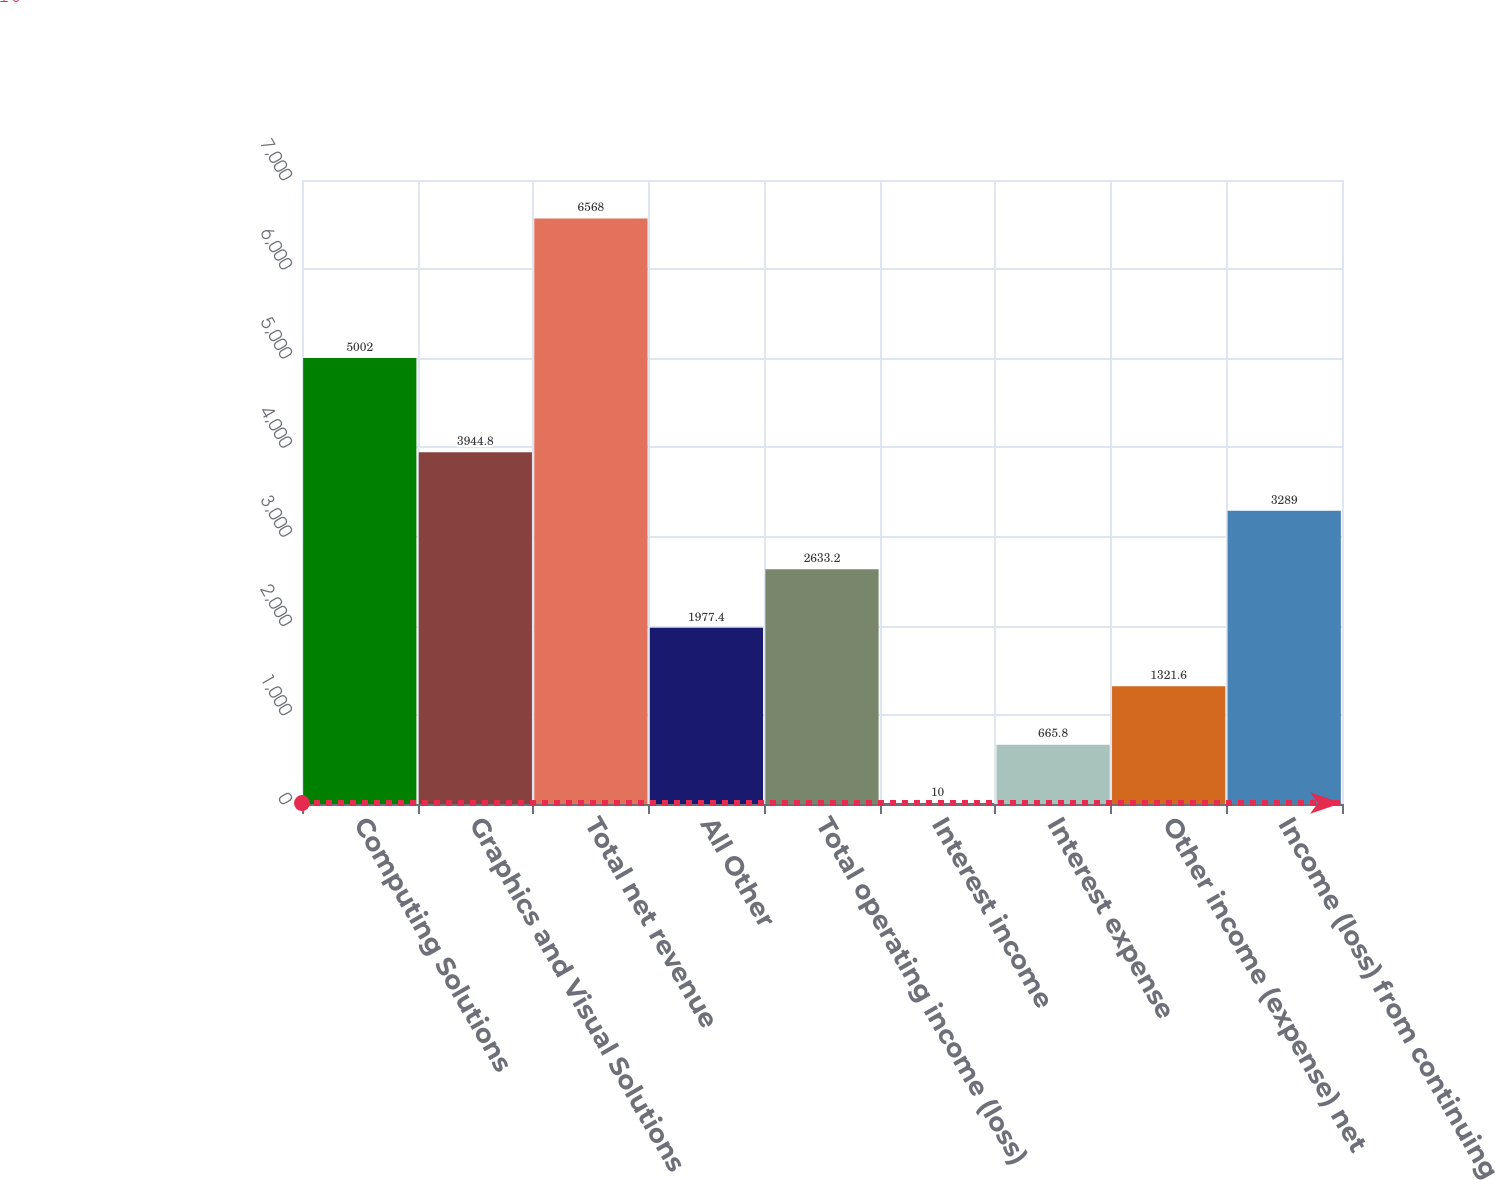Convert chart. <chart><loc_0><loc_0><loc_500><loc_500><bar_chart><fcel>Computing Solutions<fcel>Graphics and Visual Solutions<fcel>Total net revenue<fcel>All Other<fcel>Total operating income (loss)<fcel>Interest income<fcel>Interest expense<fcel>Other income (expense) net<fcel>Income (loss) from continuing<nl><fcel>5002<fcel>3944.8<fcel>6568<fcel>1977.4<fcel>2633.2<fcel>10<fcel>665.8<fcel>1321.6<fcel>3289<nl></chart> 